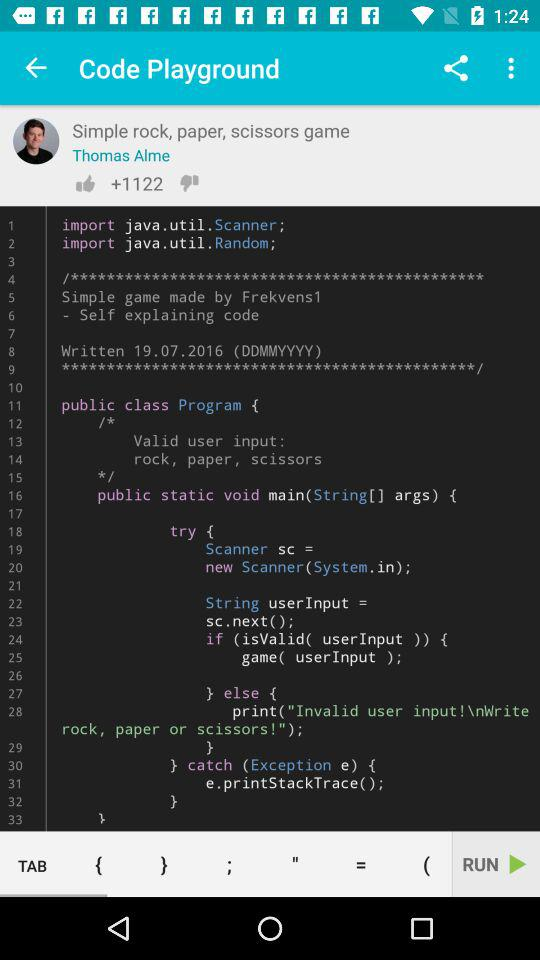How many more thumbs up than down reactions does the code playground have?
Answer the question using a single word or phrase. 1122 